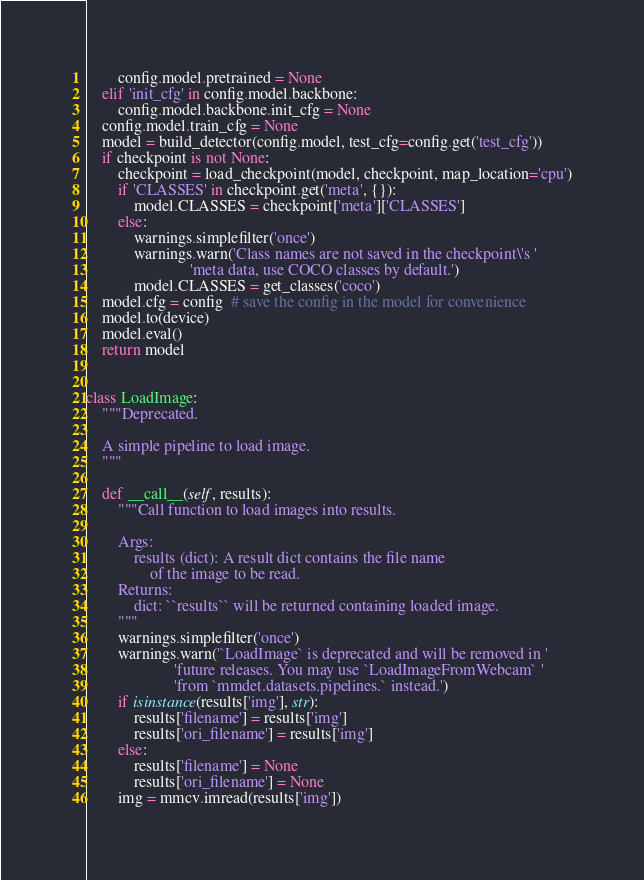<code> <loc_0><loc_0><loc_500><loc_500><_Python_>        config.model.pretrained = None
    elif 'init_cfg' in config.model.backbone:
        config.model.backbone.init_cfg = None
    config.model.train_cfg = None
    model = build_detector(config.model, test_cfg=config.get('test_cfg'))
    if checkpoint is not None:
        checkpoint = load_checkpoint(model, checkpoint, map_location='cpu')
        if 'CLASSES' in checkpoint.get('meta', {}):
            model.CLASSES = checkpoint['meta']['CLASSES']
        else:
            warnings.simplefilter('once')
            warnings.warn('Class names are not saved in the checkpoint\'s '
                          'meta data, use COCO classes by default.')
            model.CLASSES = get_classes('coco')
    model.cfg = config  # save the config in the model for convenience
    model.to(device)
    model.eval()
    return model


class LoadImage:
    """Deprecated.

    A simple pipeline to load image.
    """

    def __call__(self, results):
        """Call function to load images into results.

        Args:
            results (dict): A result dict contains the file name
                of the image to be read.
        Returns:
            dict: ``results`` will be returned containing loaded image.
        """
        warnings.simplefilter('once')
        warnings.warn('`LoadImage` is deprecated and will be removed in '
                      'future releases. You may use `LoadImageFromWebcam` '
                      'from `mmdet.datasets.pipelines.` instead.')
        if isinstance(results['img'], str):
            results['filename'] = results['img']
            results['ori_filename'] = results['img']
        else:
            results['filename'] = None
            results['ori_filename'] = None
        img = mmcv.imread(results['img'])</code> 